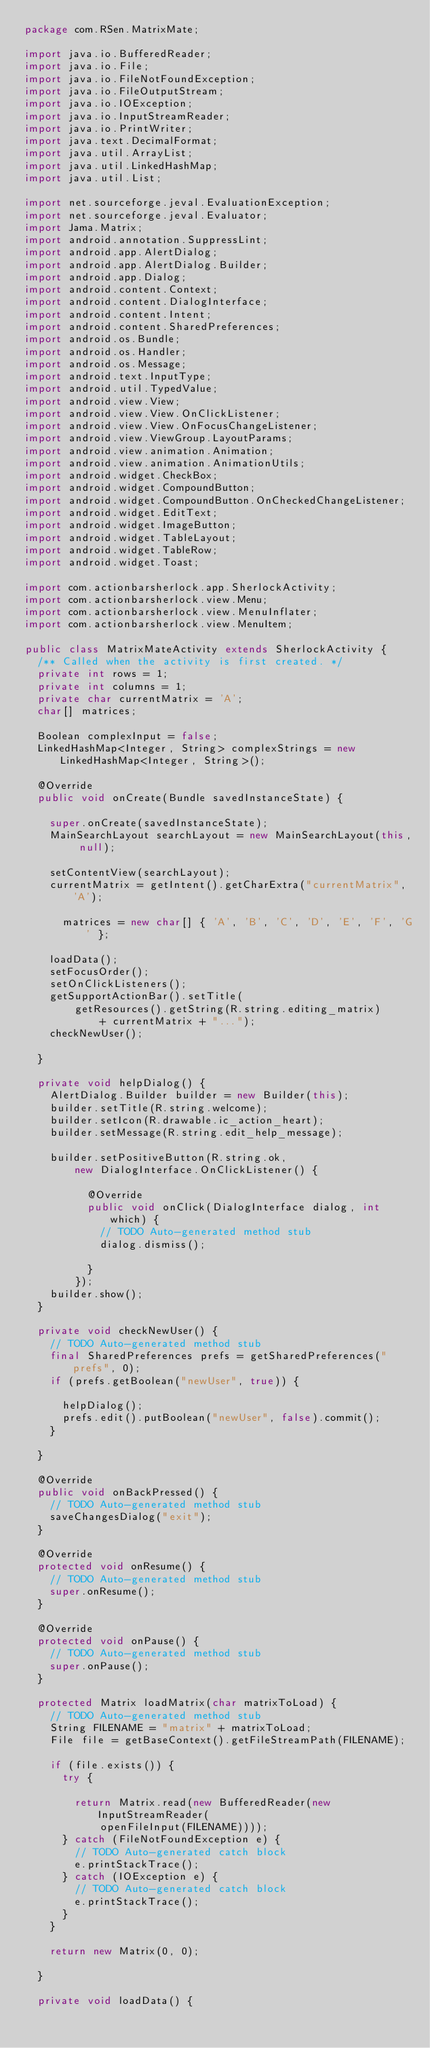Convert code to text. <code><loc_0><loc_0><loc_500><loc_500><_Java_>package com.RSen.MatrixMate;

import java.io.BufferedReader;
import java.io.File;
import java.io.FileNotFoundException;
import java.io.FileOutputStream;
import java.io.IOException;
import java.io.InputStreamReader;
import java.io.PrintWriter;
import java.text.DecimalFormat;
import java.util.ArrayList;
import java.util.LinkedHashMap;
import java.util.List;

import net.sourceforge.jeval.EvaluationException;
import net.sourceforge.jeval.Evaluator;
import Jama.Matrix;
import android.annotation.SuppressLint;
import android.app.AlertDialog;
import android.app.AlertDialog.Builder;
import android.app.Dialog;
import android.content.Context;
import android.content.DialogInterface;
import android.content.Intent;
import android.content.SharedPreferences;
import android.os.Bundle;
import android.os.Handler;
import android.os.Message;
import android.text.InputType;
import android.util.TypedValue;
import android.view.View;
import android.view.View.OnClickListener;
import android.view.View.OnFocusChangeListener;
import android.view.ViewGroup.LayoutParams;
import android.view.animation.Animation;
import android.view.animation.AnimationUtils;
import android.widget.CheckBox;
import android.widget.CompoundButton;
import android.widget.CompoundButton.OnCheckedChangeListener;
import android.widget.EditText;
import android.widget.ImageButton;
import android.widget.TableLayout;
import android.widget.TableRow;
import android.widget.Toast;

import com.actionbarsherlock.app.SherlockActivity;
import com.actionbarsherlock.view.Menu;
import com.actionbarsherlock.view.MenuInflater;
import com.actionbarsherlock.view.MenuItem;

public class MatrixMateActivity extends SherlockActivity {
	/** Called when the activity is first created. */
	private int rows = 1;
	private int columns = 1;
	private char currentMatrix = 'A';
	char[] matrices;

	Boolean complexInput = false;
	LinkedHashMap<Integer, String> complexStrings = new LinkedHashMap<Integer, String>();

	@Override
	public void onCreate(Bundle savedInstanceState) {

		super.onCreate(savedInstanceState);
		MainSearchLayout searchLayout = new MainSearchLayout(this, null);

		setContentView(searchLayout);
		currentMatrix = getIntent().getCharExtra("currentMatrix", 'A');
		
			matrices = new char[] { 'A', 'B', 'C', 'D', 'E', 'F', 'G' };
		
		loadData();
		setFocusOrder();
		setOnClickListeners();
		getSupportActionBar().setTitle(
				getResources().getString(R.string.editing_matrix)
						+ currentMatrix + "...");
		checkNewUser();

	}

	private void helpDialog() {
		AlertDialog.Builder builder = new Builder(this);
		builder.setTitle(R.string.welcome);
		builder.setIcon(R.drawable.ic_action_heart);
		builder.setMessage(R.string.edit_help_message);

		builder.setPositiveButton(R.string.ok,
				new DialogInterface.OnClickListener() {

					@Override
					public void onClick(DialogInterface dialog, int which) {
						// TODO Auto-generated method stub
						dialog.dismiss();

					}
				});
		builder.show();
	}

	private void checkNewUser() {
		// TODO Auto-generated method stub
		final SharedPreferences prefs = getSharedPreferences("prefs", 0);
		if (prefs.getBoolean("newUser", true)) {

			helpDialog();
			prefs.edit().putBoolean("newUser", false).commit();
		}

	}

	@Override
	public void onBackPressed() {
		// TODO Auto-generated method stub
		saveChangesDialog("exit");
	}

	@Override
	protected void onResume() {
		// TODO Auto-generated method stub
		super.onResume();
	}

	@Override
	protected void onPause() {
		// TODO Auto-generated method stub
		super.onPause();
	}

	protected Matrix loadMatrix(char matrixToLoad) {
		// TODO Auto-generated method stub
		String FILENAME = "matrix" + matrixToLoad;
		File file = getBaseContext().getFileStreamPath(FILENAME);

		if (file.exists()) {
			try {

				return Matrix.read(new BufferedReader(new InputStreamReader(
						openFileInput(FILENAME))));
			} catch (FileNotFoundException e) {
				// TODO Auto-generated catch block
				e.printStackTrace();
			} catch (IOException e) {
				// TODO Auto-generated catch block
				e.printStackTrace();
			}
		}

		return new Matrix(0, 0);

	}

	private void loadData() {</code> 